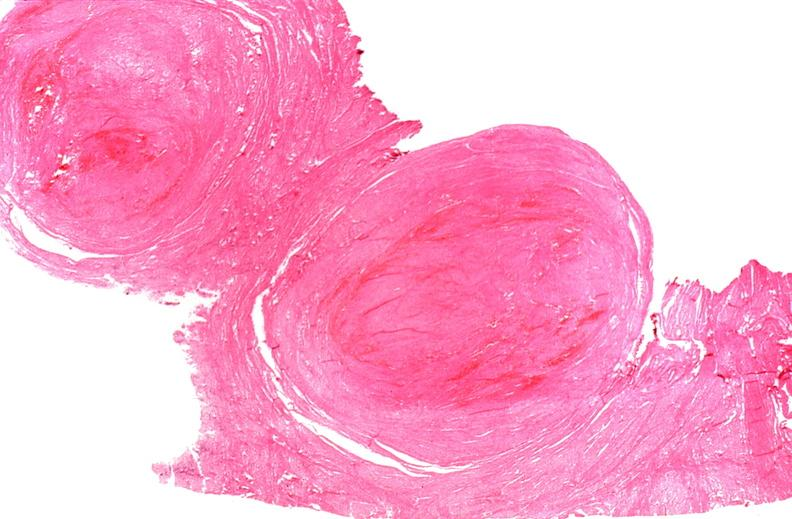what is present?
Answer the question using a single word or phrase. Female reproductive 